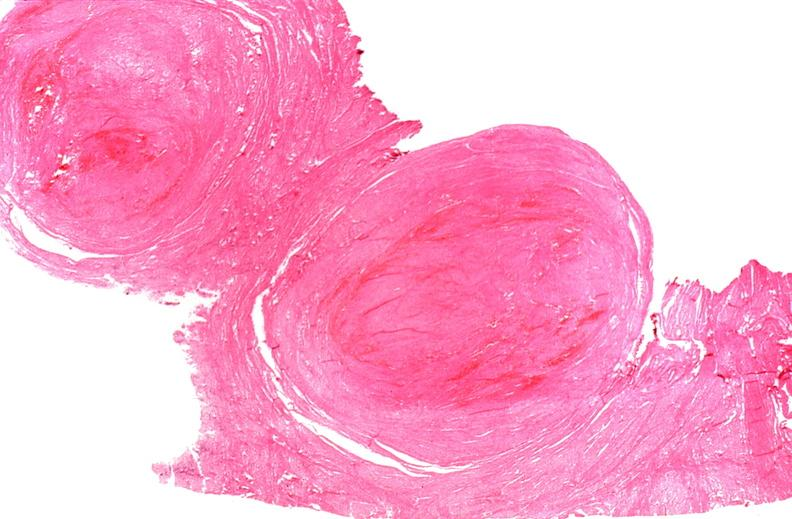what is present?
Answer the question using a single word or phrase. Female reproductive 